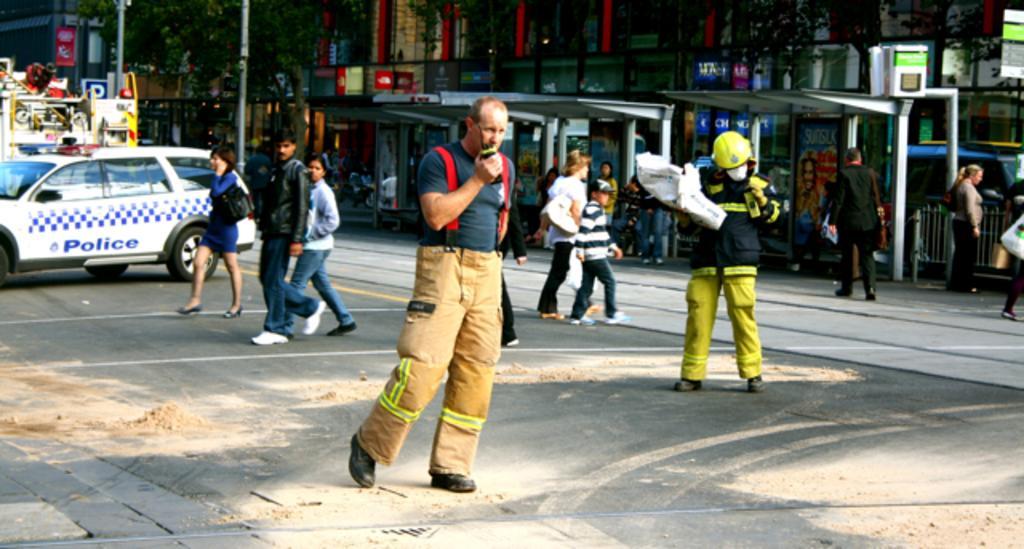Could you give a brief overview of what you see in this image? In the image there are many people walking on the road. And also there is a vehicle. Behind them there are roofs with poles and also there are posters. In the background there are buildings with walls, posters and glasses. And also there are poles with sign boards and trees. 